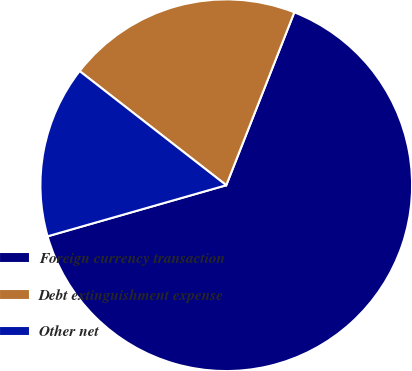<chart> <loc_0><loc_0><loc_500><loc_500><pie_chart><fcel>Foreign currency transaction<fcel>Debt extinguishment expense<fcel>Other net<nl><fcel>64.6%<fcel>20.44%<fcel>14.96%<nl></chart> 